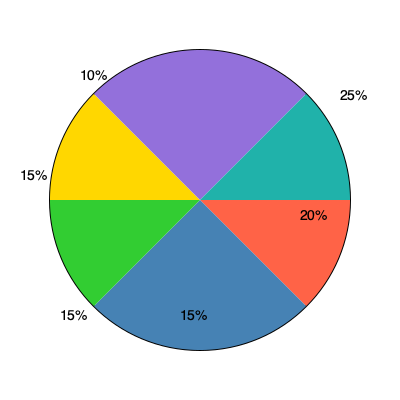A market research team has presented you with this pie chart showing the market share distribution of six competing products. The chart seems to have an inconsistency. What is the total percentage represented in this pie chart, and what error does this indicate in the data analysis? To solve this problem, we need to follow these steps:

1. Add up all the percentages shown in the pie chart:
   $25\% + 20\% + 15\% + 15\% + 15\% + 10\% = 100\%$

2. Observe that the total adds up to 100%, which is correct for a pie chart representation.

3. However, visually inspect the pie chart:
   - The red slice (25%) appears to be exactly one quarter of the circle, which is correct.
   - The blue slice (20%) appears to be less than one-fifth of the circle, which is inconsistent with its label.
   - The other slices also appear to be inconsistent with their labeled percentages.

4. A correctly constructed pie chart should have slices proportional to their percentages, with the entire circle representing 100%.

5. In this case, while the percentages add up to 100%, the visual representation does not match these percentages. This indicates an error in the graphical representation of the data, not in the percentage calculations.

6. This type of error could occur if:
   - The chart was created manually without proper attention to slice sizes.
   - There was a software glitch in the chart creation process.
   - The chart was intentionally manipulated to misrepresent the data.

Therefore, the total percentage is 100%, but the visual representation is incorrect, indicating an error in the graphical depiction of the market share data, not in the underlying percentages.
Answer: 100%; graphical misrepresentation 